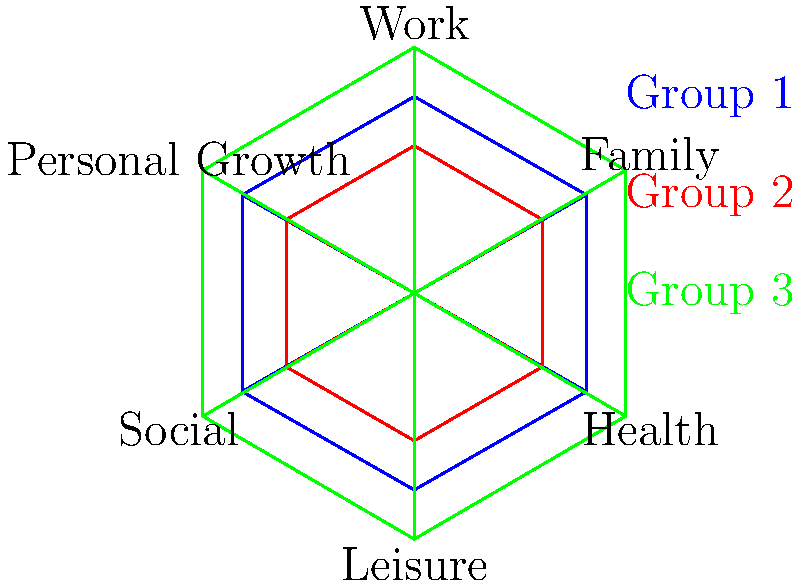Based on the radar charts representing work-life balance profiles for three groups, which group appears to have the most balanced distribution across all life domains? To determine which group has the most balanced distribution across all life domains, we need to analyze the radar charts for each group:

1. Examine Group 1 (blue):
   - Moderate scores across all domains
   - Relatively balanced, but slightly lower in Work and Leisure

2. Examine Group 2 (red):
   - Lower scores across all domains compared to other groups
   - Relatively balanced, but overall lower engagement in all areas

3. Examine Group 3 (green):
   - Higher scores across all domains compared to other groups
   - Shows more variation between domains
   - Notably higher in Work, Family, and Personal Growth
   - Slightly lower in Health, Leisure, and Social domains

4. Compare the groups:
   - Group 1 shows the most consistent distribution across all domains
   - Group 2 is balanced but at a lower level overall
   - Group 3 shows the highest engagement but more variation between domains

5. Conclusion:
   Group 1 (blue) demonstrates the most balanced distribution across all life domains, as it maintains moderate and consistent scores without significant peaks or valleys in any particular area.
Answer: Group 1 (blue) 